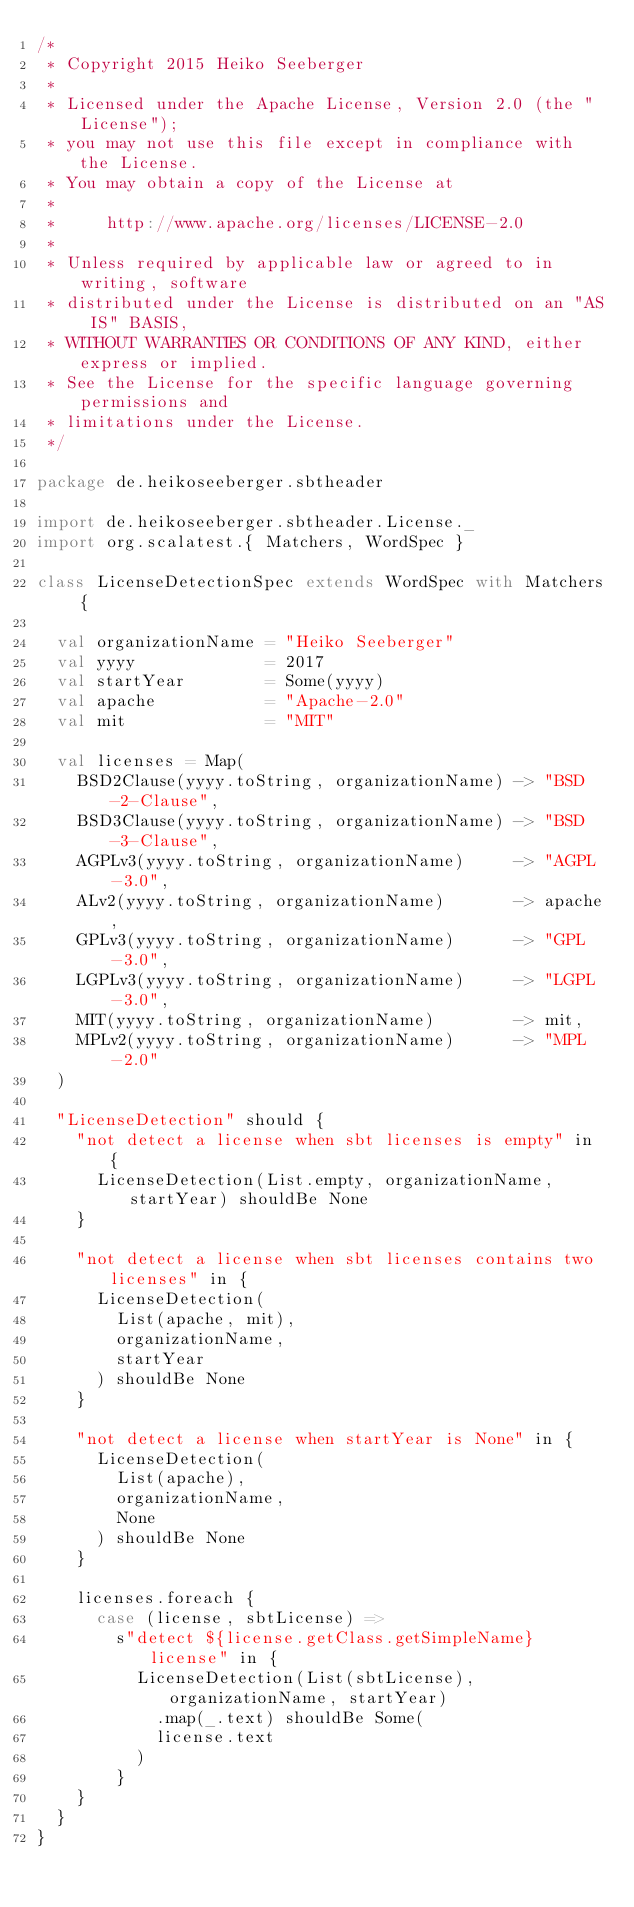<code> <loc_0><loc_0><loc_500><loc_500><_Scala_>/*
 * Copyright 2015 Heiko Seeberger
 *
 * Licensed under the Apache License, Version 2.0 (the "License");
 * you may not use this file except in compliance with the License.
 * You may obtain a copy of the License at
 *
 *     http://www.apache.org/licenses/LICENSE-2.0
 *
 * Unless required by applicable law or agreed to in writing, software
 * distributed under the License is distributed on an "AS IS" BASIS,
 * WITHOUT WARRANTIES OR CONDITIONS OF ANY KIND, either express or implied.
 * See the License for the specific language governing permissions and
 * limitations under the License.
 */

package de.heikoseeberger.sbtheader

import de.heikoseeberger.sbtheader.License._
import org.scalatest.{ Matchers, WordSpec }

class LicenseDetectionSpec extends WordSpec with Matchers {

  val organizationName = "Heiko Seeberger"
  val yyyy             = 2017
  val startYear        = Some(yyyy)
  val apache           = "Apache-2.0"
  val mit              = "MIT"

  val licenses = Map(
    BSD2Clause(yyyy.toString, organizationName) -> "BSD-2-Clause",
    BSD3Clause(yyyy.toString, organizationName) -> "BSD-3-Clause",
    AGPLv3(yyyy.toString, organizationName)     -> "AGPL-3.0",
    ALv2(yyyy.toString, organizationName)       -> apache,
    GPLv3(yyyy.toString, organizationName)      -> "GPL-3.0",
    LGPLv3(yyyy.toString, organizationName)     -> "LGPL-3.0",
    MIT(yyyy.toString, organizationName)        -> mit,
    MPLv2(yyyy.toString, organizationName)      -> "MPL-2.0"
  )

  "LicenseDetection" should {
    "not detect a license when sbt licenses is empty" in {
      LicenseDetection(List.empty, organizationName, startYear) shouldBe None
    }

    "not detect a license when sbt licenses contains two licenses" in {
      LicenseDetection(
        List(apache, mit),
        organizationName,
        startYear
      ) shouldBe None
    }

    "not detect a license when startYear is None" in {
      LicenseDetection(
        List(apache),
        organizationName,
        None
      ) shouldBe None
    }

    licenses.foreach {
      case (license, sbtLicense) =>
        s"detect ${license.getClass.getSimpleName} license" in {
          LicenseDetection(List(sbtLicense), organizationName, startYear)
            .map(_.text) shouldBe Some(
            license.text
          )
        }
    }
  }
}
</code> 